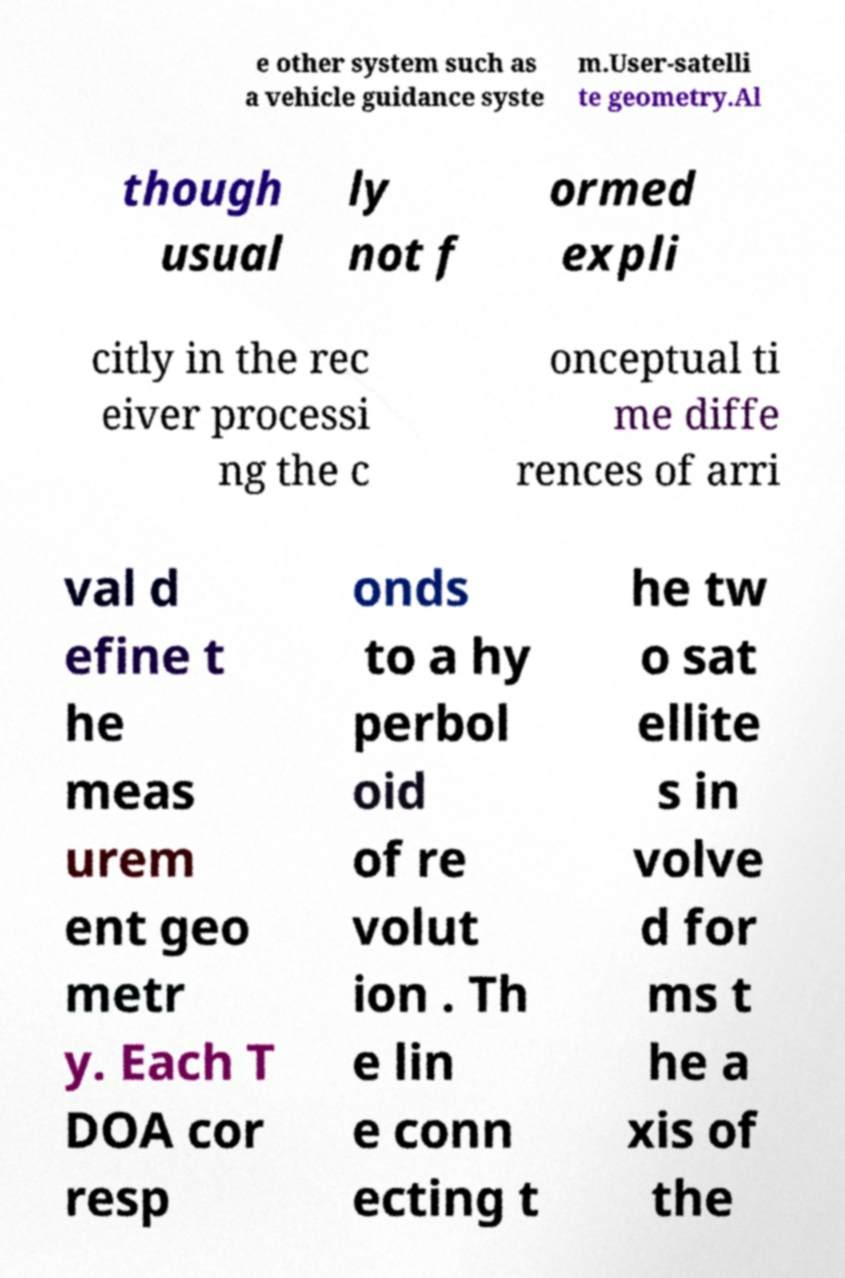Please identify and transcribe the text found in this image. e other system such as a vehicle guidance syste m.User-satelli te geometry.Al though usual ly not f ormed expli citly in the rec eiver processi ng the c onceptual ti me diffe rences of arri val d efine t he meas urem ent geo metr y. Each T DOA cor resp onds to a hy perbol oid of re volut ion . Th e lin e conn ecting t he tw o sat ellite s in volve d for ms t he a xis of the 